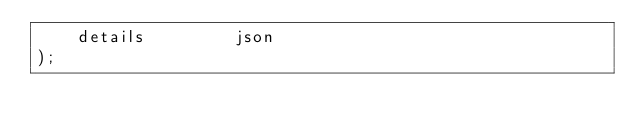Convert code to text. <code><loc_0><loc_0><loc_500><loc_500><_SQL_>    details         json
);
</code> 